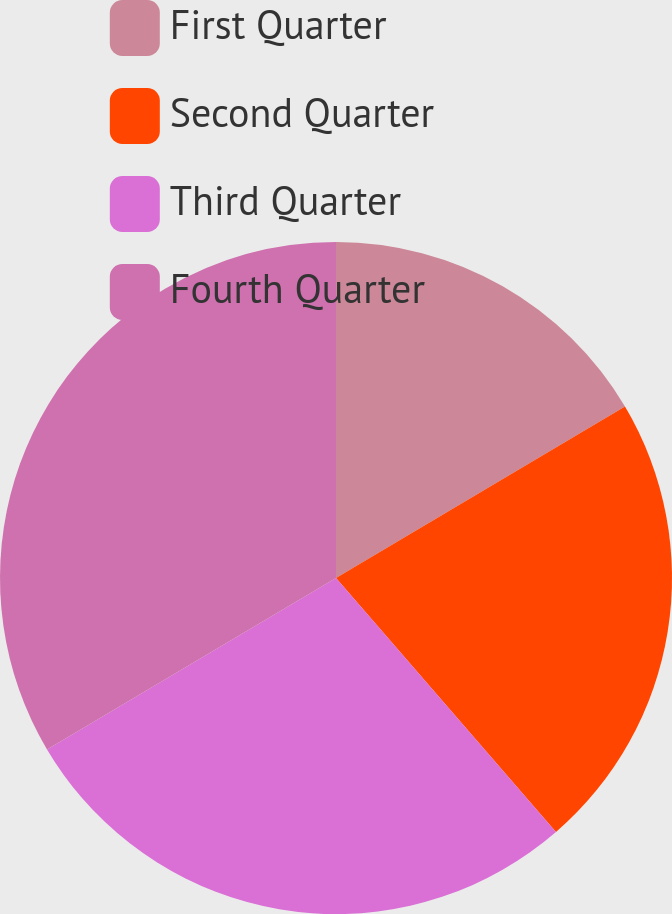Convert chart. <chart><loc_0><loc_0><loc_500><loc_500><pie_chart><fcel>First Quarter<fcel>Second Quarter<fcel>Third Quarter<fcel>Fourth Quarter<nl><fcel>16.48%<fcel>22.16%<fcel>27.84%<fcel>33.52%<nl></chart> 